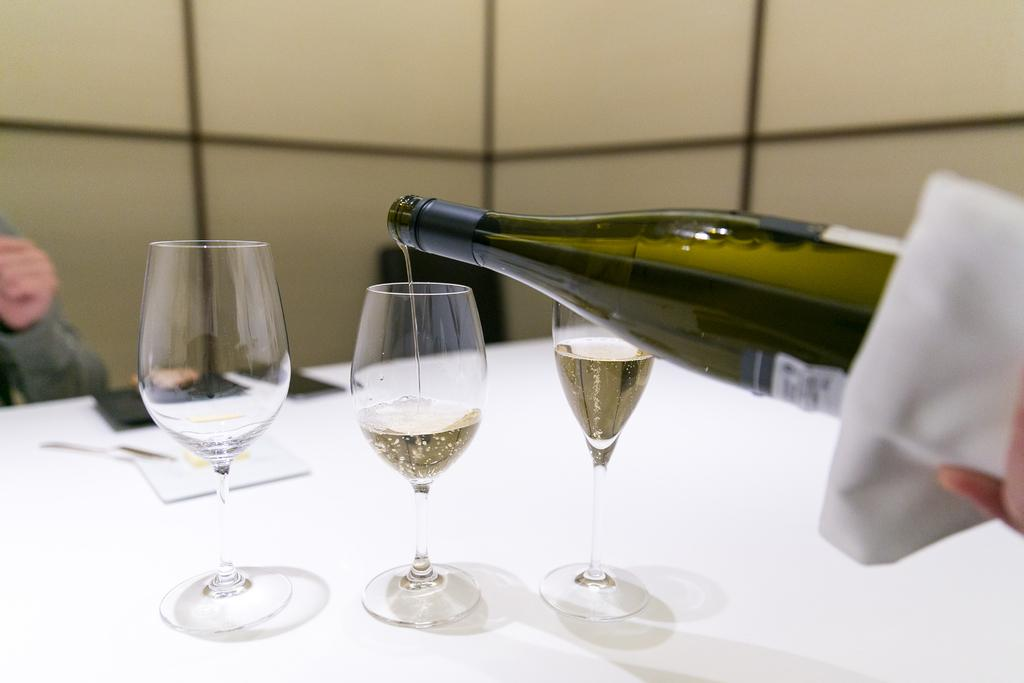How many glasses are on the table in the image? There are 3 glasses on the table. What else is on the table besides the glasses? There is a bottle on the table. What can be seen in the background of the image? There is a wall in the background. Can you describe any human presence in the image? A person's hand is visible in the background. What is the maid doing in the image? There is no maid present in the image. How does the person's hand look in the image? The image does not provide a detailed description of the person's hand, so it is not possible to answer how it looks. 